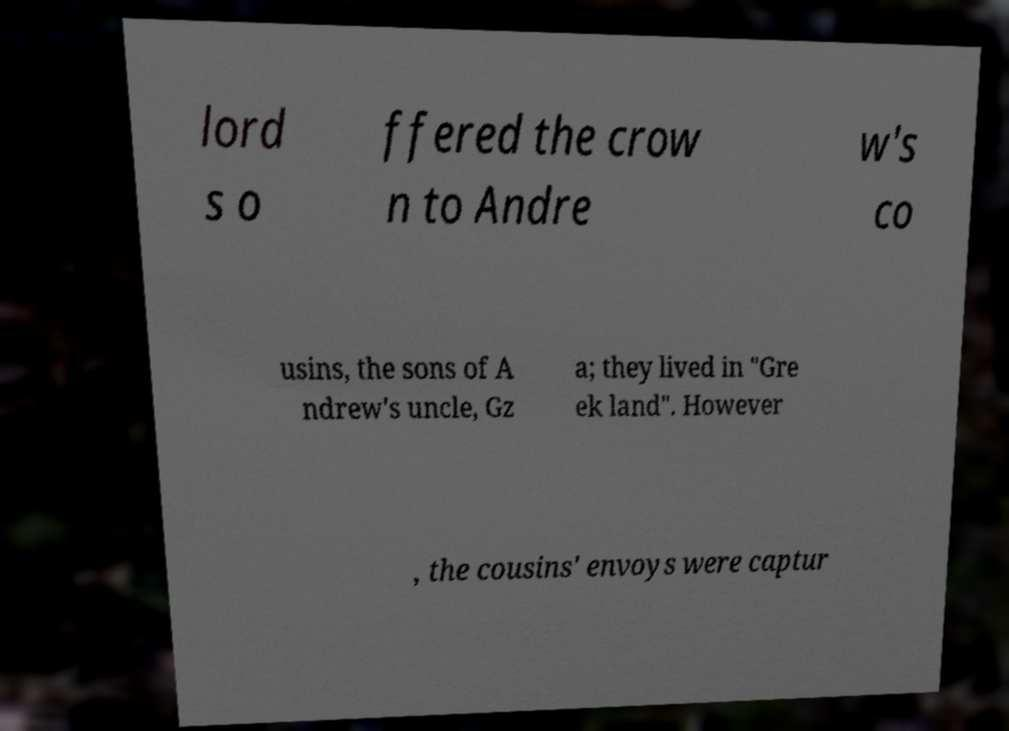What messages or text are displayed in this image? I need them in a readable, typed format. lord s o ffered the crow n to Andre w's co usins, the sons of A ndrew's uncle, Gz a; they lived in "Gre ek land". However , the cousins' envoys were captur 